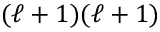Convert formula to latex. <formula><loc_0><loc_0><loc_500><loc_500>( \ell + 1 ) ( \ell + 1 )</formula> 